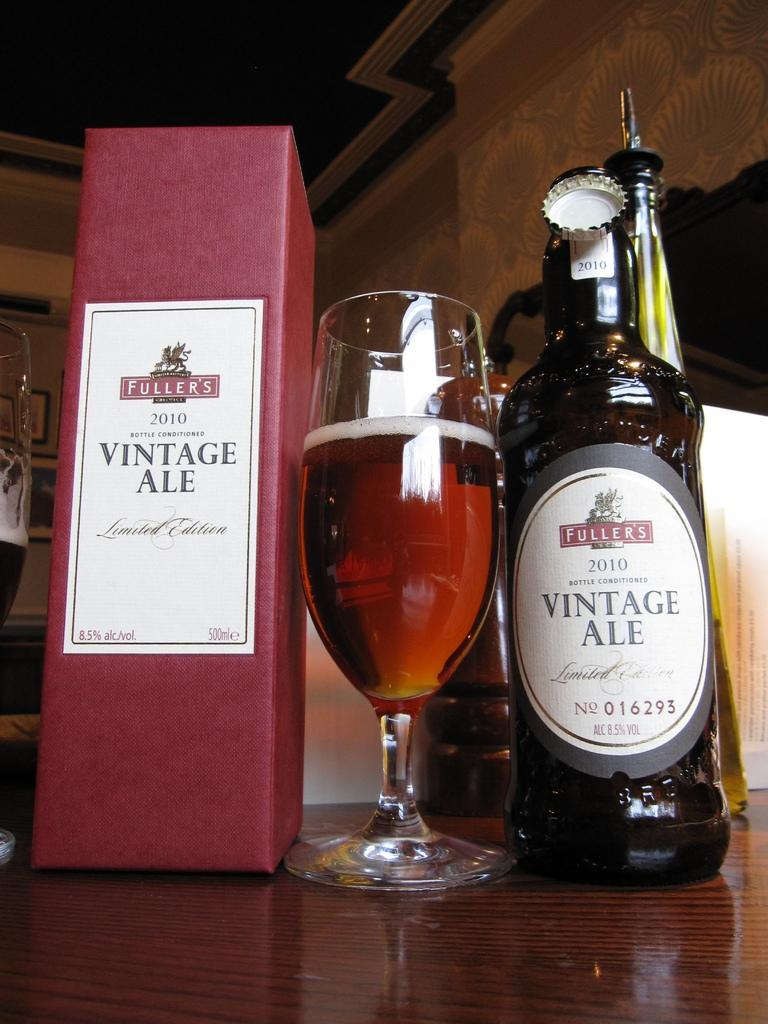<image>
Offer a succinct explanation of the picture presented. A bottle of Fuller's Vintage Ale is next to a glass of the ale and the box. 